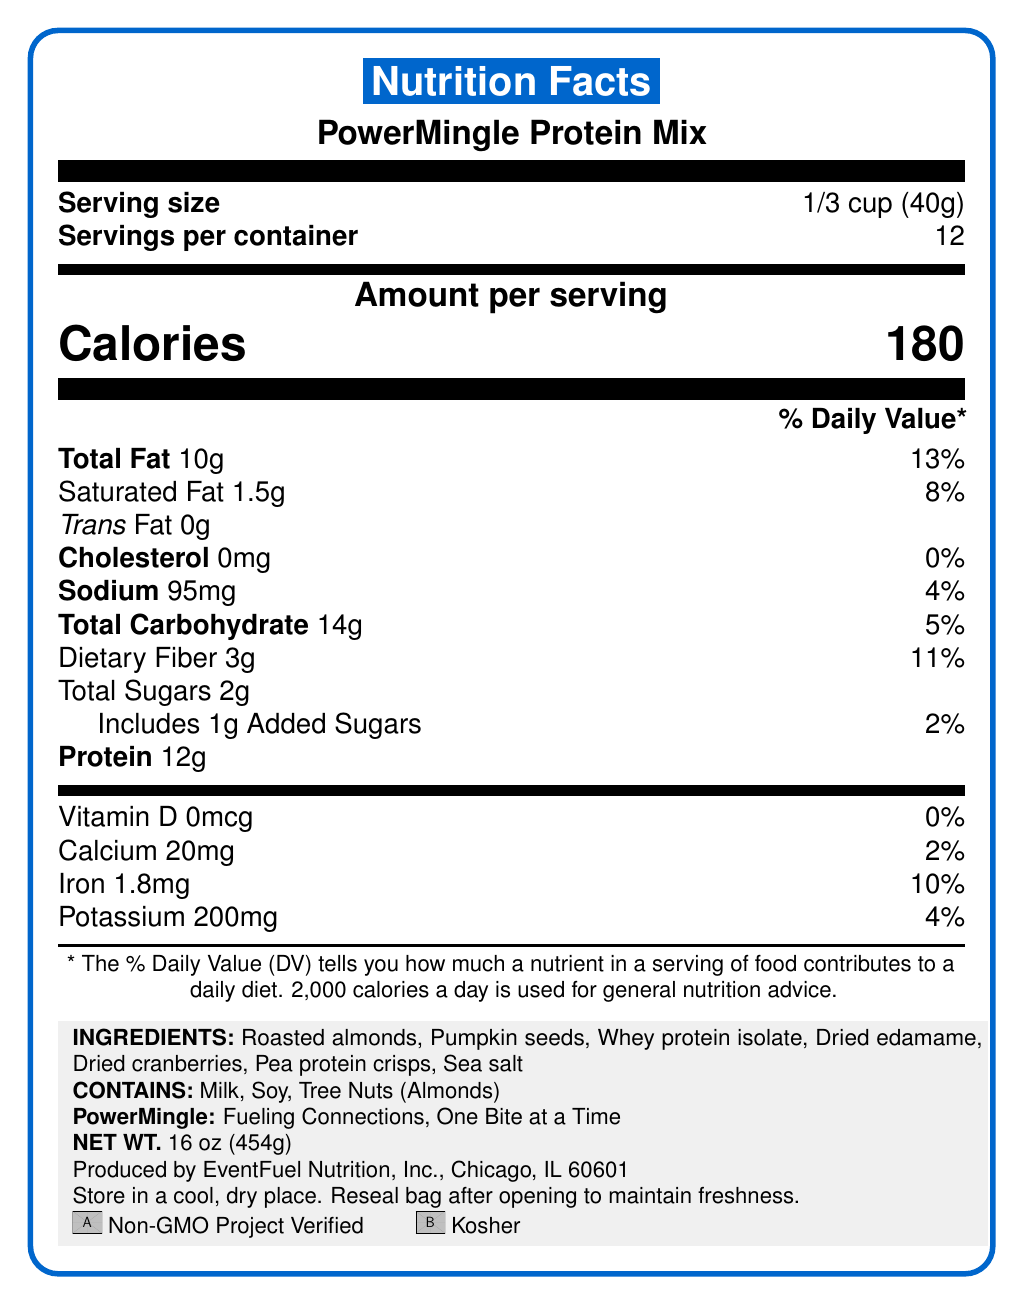what is the serving size of PowerMingle Protein Mix? The document lists the serving size as 1/3 cup, which is equivalent to 40 grams.
Answer: 1/3 cup (40g) how many servings are in the container? The document specifies that there are 12 servings per container.
Answer: 12 how many calories are in one serving of this mix? The Nutrition Facts section states that one serving contains 180 calories.
Answer: 180 what is the amount of dietary fiber per serving? The document lists 3 grams of dietary fiber per serving, providing 11% of the daily value.
Answer: 3g which nutrient contributes to 0% of the daily value? According to the document, Vitamin D has 0mcg per serving, contributing 0% to the daily value.
Answer: Vitamin D which ingredients listed contain allergens? A. Roasted almonds and edible gold leaf B. Whey protein isolate and sea salt C. Roasted almonds and dried edamame The allergen information specifies that the mix contains milk, soy, and tree nuts (almonds).
Answer: C how much protein is there per serving? A. 5g B. 8g C. 12g D. 18g Each serving of this mix contains 12 grams of protein.
Answer: C is this product kosher certified? (True/False) The document includes a certification icon that indicates the product is Kosher.
Answer: True what types of fats are included in the mix? The document lists 10 grams of total fat with 1.5 grams being saturated fat, and no trans fat.
Answer: Total Fat 10g, Saturated Fat 1.5g, Trans Fat 0g how much added sugar is in one serving? The document specifies that there is 1 gram of added sugars per serving, contributing 2% to the daily value.
Answer: 1g what is the net weight of the entire package? The document states that the net weight of the package is 16 ounces, which is equivalent to 454 grams.
Answer: 16 oz (454g) does the mix contain any artificial flavors or preservatives? The marketing claims section mentions that there are no artificial flavors or preservatives in this product.
Answer: No summarize the key features indicated in the drink’s nutrition label. This summary details the nutritional value, ingredients, and certifiable qualities from the document.
Answer: PowerMingle Protein Mix offers a nutrient-dense snack with 180 calories per serving, primarily derived from 12g of protein and 10g of fat. Composed of wholesome ingredients like roasted almonds, pumpkin seeds, and dried edamame, the mix stands out due to its good source of fiber and absence of artificial additives. Each serving also includes a minimal amount of sodium (95mg) and added sugars (1g). Certified Non-GMO and Kosher, it’s a perfect option for networking events. what other products does EventFuel Nutrition, Inc. produce? The document does not provide details on other products manufactured by EventFuel Nutrition, Inc.
Answer: Not enough information 